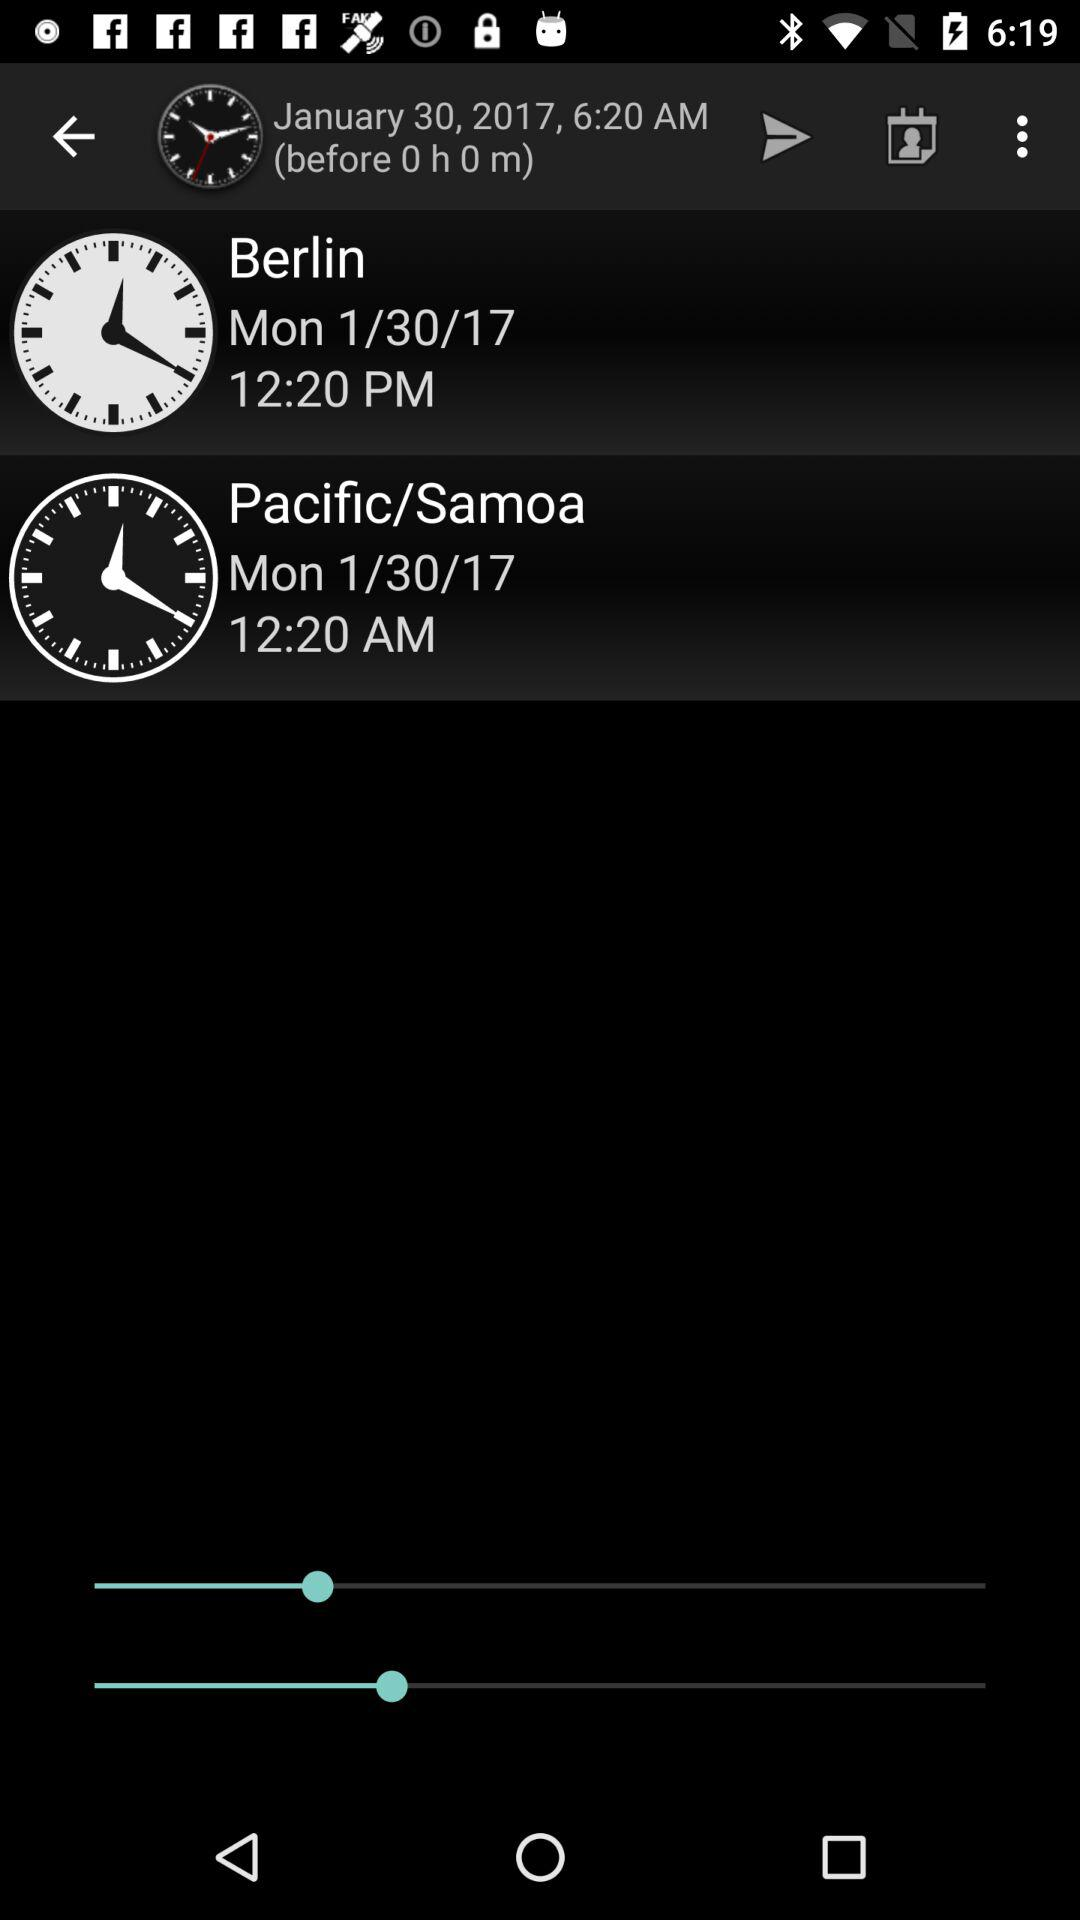What is the date of Berlin? The date of Berlin is 1/30/17. 